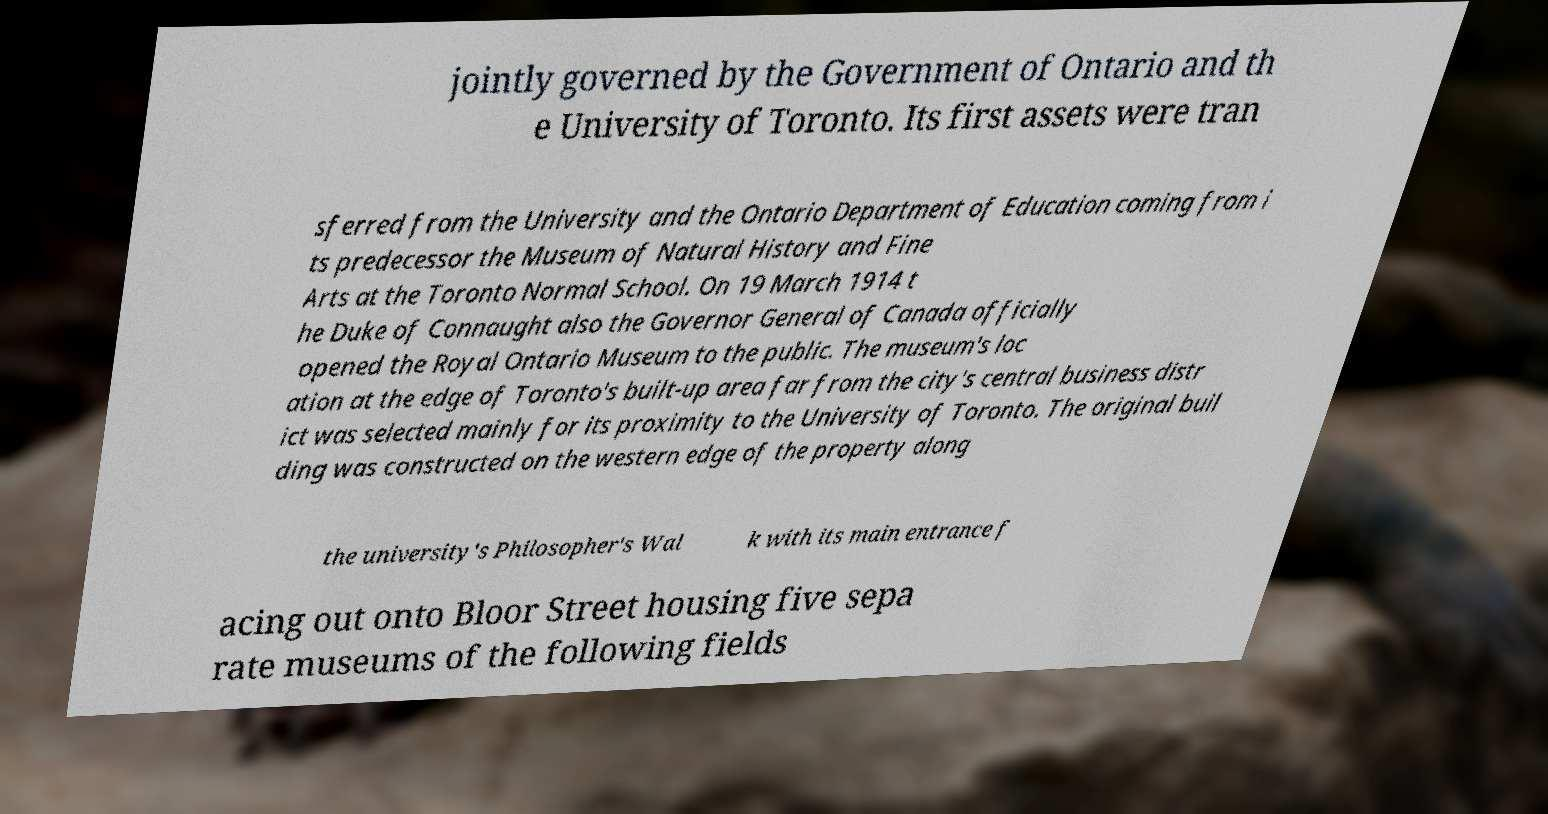Could you assist in decoding the text presented in this image and type it out clearly? jointly governed by the Government of Ontario and th e University of Toronto. Its first assets were tran sferred from the University and the Ontario Department of Education coming from i ts predecessor the Museum of Natural History and Fine Arts at the Toronto Normal School. On 19 March 1914 t he Duke of Connaught also the Governor General of Canada officially opened the Royal Ontario Museum to the public. The museum's loc ation at the edge of Toronto's built-up area far from the city's central business distr ict was selected mainly for its proximity to the University of Toronto. The original buil ding was constructed on the western edge of the property along the university's Philosopher's Wal k with its main entrance f acing out onto Bloor Street housing five sepa rate museums of the following fields 